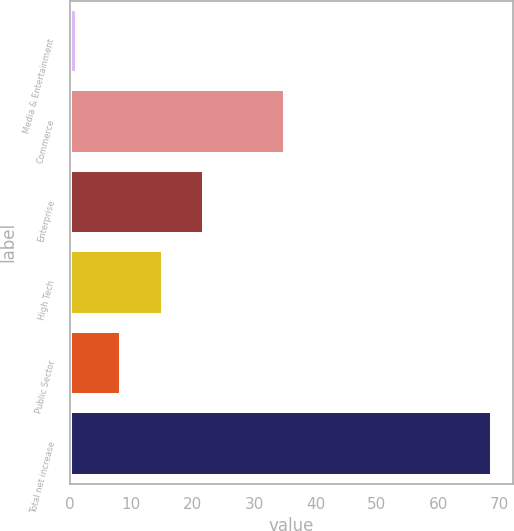<chart> <loc_0><loc_0><loc_500><loc_500><bar_chart><fcel>Media & Entertainment<fcel>Commerce<fcel>Enterprise<fcel>High Tech<fcel>Public Sector<fcel>Total net increase<nl><fcel>1.2<fcel>35<fcel>21.92<fcel>15.16<fcel>8.4<fcel>68.8<nl></chart> 